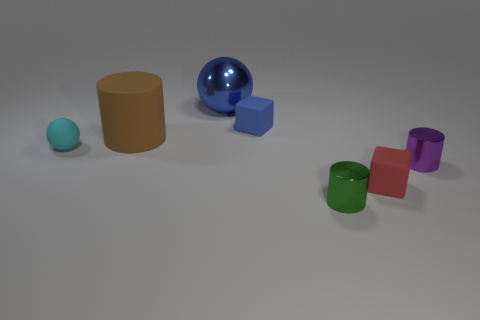There is a rubber thing that is on the left side of the large brown cylinder; does it have the same shape as the small shiny thing behind the green metal cylinder?
Offer a terse response. No. What number of blocks are blue metallic things or purple objects?
Your answer should be very brief. 0. Are there fewer spheres that are to the right of the large blue metallic sphere than large brown things?
Provide a short and direct response. Yes. How many other objects are the same material as the red thing?
Your answer should be compact. 3. Is the blue metal object the same size as the brown cylinder?
Your answer should be compact. Yes. How many things are cylinders behind the small cyan rubber sphere or tiny green objects?
Offer a very short reply. 2. What material is the small cube that is to the right of the small thing in front of the small red matte object?
Your answer should be compact. Rubber. Are there any other purple metallic objects of the same shape as the big metallic object?
Provide a succinct answer. No. Do the blue metallic ball and the cylinder that is on the left side of the tiny blue object have the same size?
Your response must be concise. Yes. What number of objects are rubber cubes that are in front of the purple metal object or small things that are on the right side of the shiny sphere?
Provide a succinct answer. 4. 